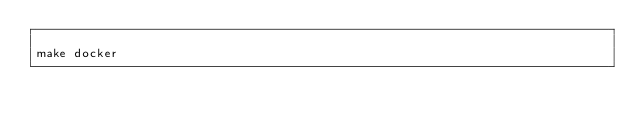Convert code to text. <code><loc_0><loc_0><loc_500><loc_500><_Bash_>
make docker

</code> 